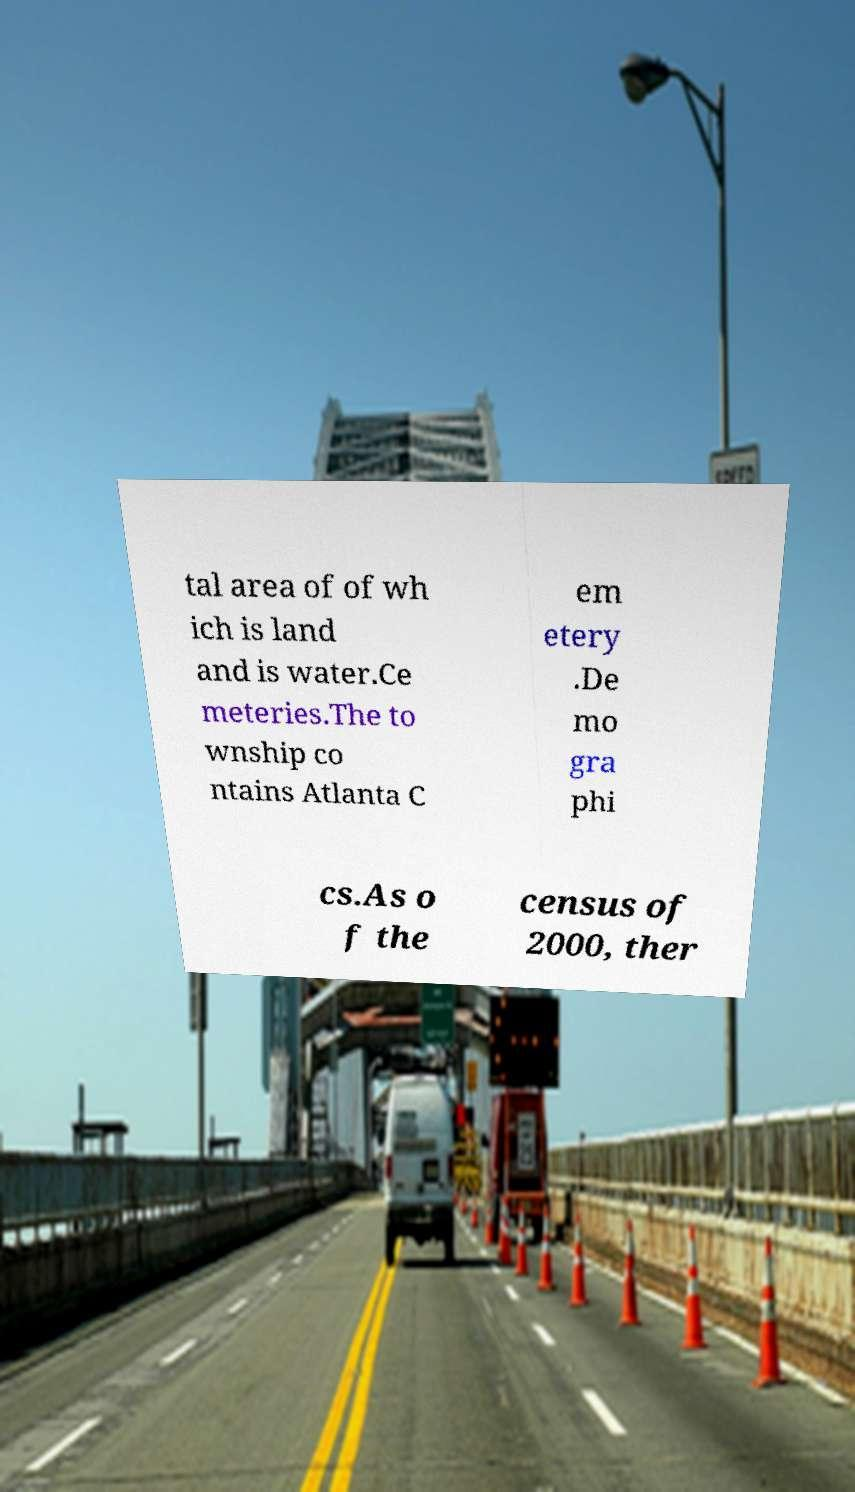Could you extract and type out the text from this image? tal area of of wh ich is land and is water.Ce meteries.The to wnship co ntains Atlanta C em etery .De mo gra phi cs.As o f the census of 2000, ther 